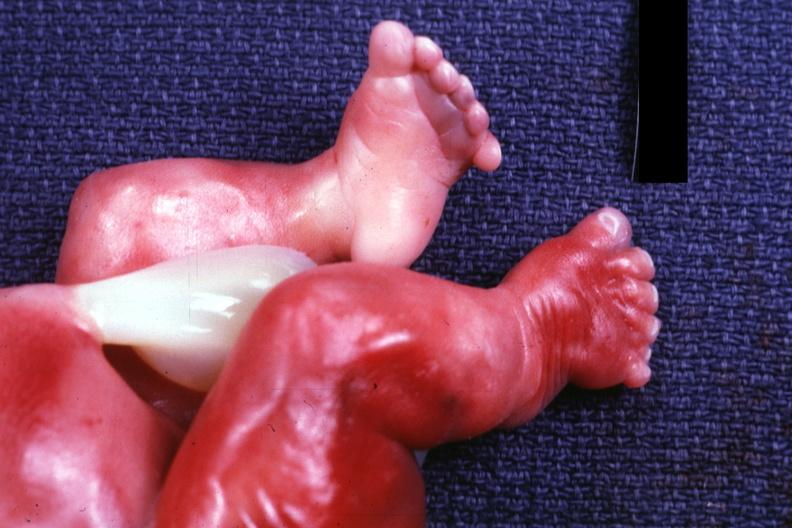what is present?
Answer the question using a single word or phrase. Six digits 